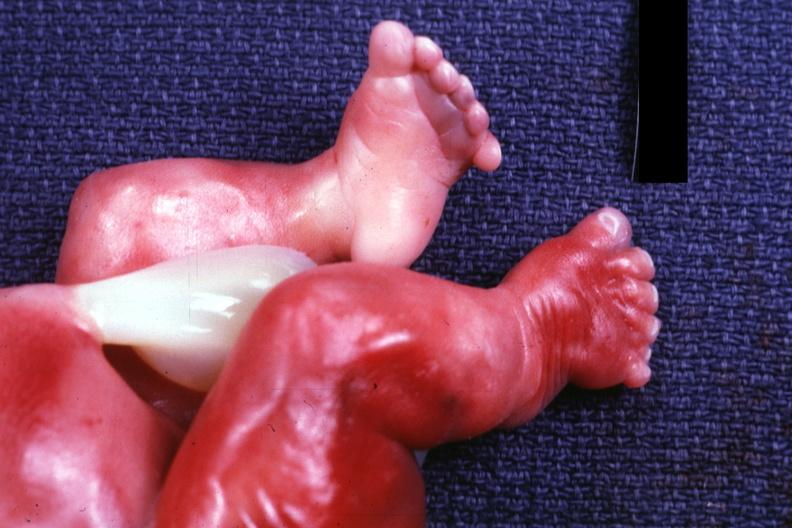what is present?
Answer the question using a single word or phrase. Six digits 